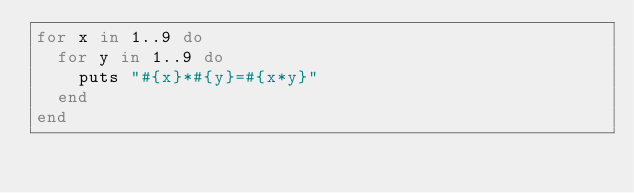Convert code to text. <code><loc_0><loc_0><loc_500><loc_500><_Ruby_>for x in 1..9 do
	for y in 1..9 do
		puts "#{x}*#{y}=#{x*y}"
	end
end</code> 